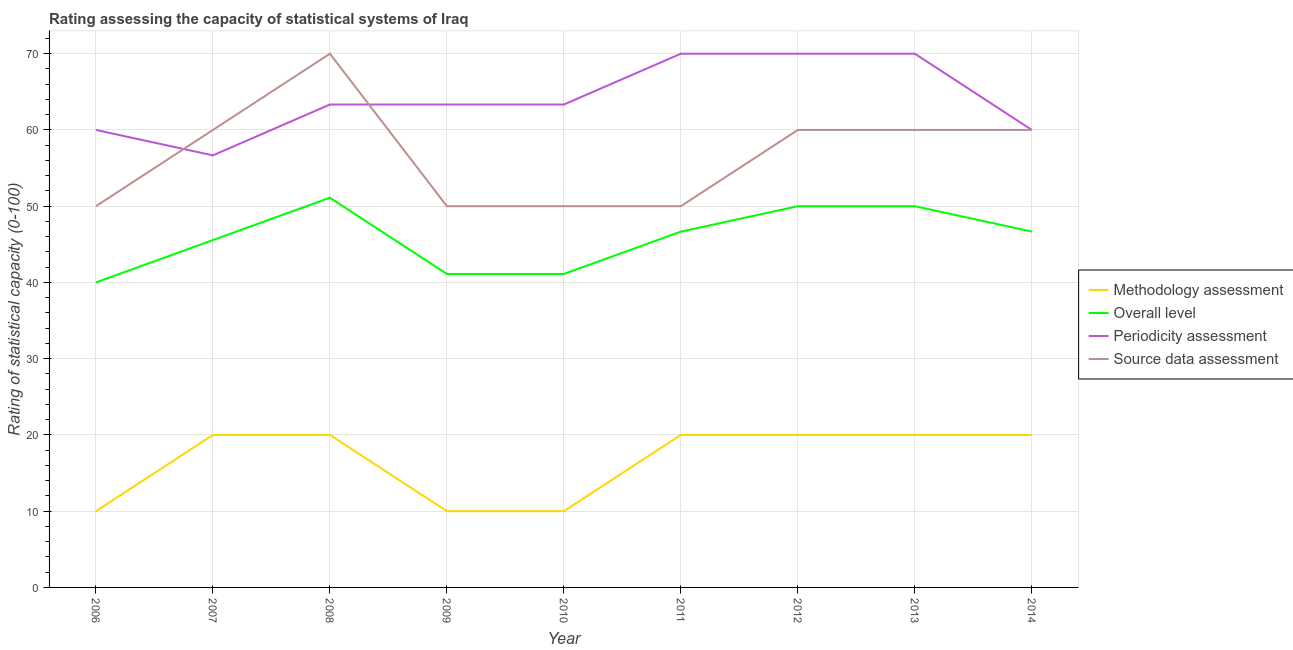Does the line corresponding to overall level rating intersect with the line corresponding to source data assessment rating?
Your response must be concise. No. What is the methodology assessment rating in 2010?
Your answer should be very brief. 10. Across all years, what is the maximum methodology assessment rating?
Your answer should be very brief. 20. Across all years, what is the minimum periodicity assessment rating?
Make the answer very short. 56.67. In which year was the methodology assessment rating minimum?
Ensure brevity in your answer.  2006. What is the total periodicity assessment rating in the graph?
Give a very brief answer. 576.67. What is the difference between the periodicity assessment rating in 2006 and that in 2009?
Provide a succinct answer. -3.33. What is the difference between the overall level rating in 2006 and the periodicity assessment rating in 2010?
Offer a very short reply. -23.33. What is the average source data assessment rating per year?
Offer a terse response. 56.67. What is the difference between the highest and the second highest periodicity assessment rating?
Provide a short and direct response. 0. What is the difference between the highest and the lowest methodology assessment rating?
Keep it short and to the point. 10. In how many years, is the source data assessment rating greater than the average source data assessment rating taken over all years?
Offer a very short reply. 5. Is it the case that in every year, the sum of the methodology assessment rating and overall level rating is greater than the periodicity assessment rating?
Your answer should be very brief. No. Is the periodicity assessment rating strictly greater than the source data assessment rating over the years?
Provide a succinct answer. No. Is the methodology assessment rating strictly less than the source data assessment rating over the years?
Provide a succinct answer. Yes. How many lines are there?
Your answer should be very brief. 4. How many years are there in the graph?
Provide a short and direct response. 9. Are the values on the major ticks of Y-axis written in scientific E-notation?
Ensure brevity in your answer.  No. Does the graph contain any zero values?
Give a very brief answer. No. How are the legend labels stacked?
Offer a terse response. Vertical. What is the title of the graph?
Your response must be concise. Rating assessing the capacity of statistical systems of Iraq. What is the label or title of the Y-axis?
Provide a short and direct response. Rating of statistical capacity (0-100). What is the Rating of statistical capacity (0-100) in Methodology assessment in 2006?
Your response must be concise. 10. What is the Rating of statistical capacity (0-100) of Periodicity assessment in 2006?
Make the answer very short. 60. What is the Rating of statistical capacity (0-100) in Source data assessment in 2006?
Give a very brief answer. 50. What is the Rating of statistical capacity (0-100) in Methodology assessment in 2007?
Offer a terse response. 20. What is the Rating of statistical capacity (0-100) in Overall level in 2007?
Ensure brevity in your answer.  45.56. What is the Rating of statistical capacity (0-100) of Periodicity assessment in 2007?
Keep it short and to the point. 56.67. What is the Rating of statistical capacity (0-100) of Overall level in 2008?
Make the answer very short. 51.11. What is the Rating of statistical capacity (0-100) in Periodicity assessment in 2008?
Make the answer very short. 63.33. What is the Rating of statistical capacity (0-100) of Methodology assessment in 2009?
Your answer should be compact. 10. What is the Rating of statistical capacity (0-100) of Overall level in 2009?
Your response must be concise. 41.11. What is the Rating of statistical capacity (0-100) of Periodicity assessment in 2009?
Give a very brief answer. 63.33. What is the Rating of statistical capacity (0-100) in Methodology assessment in 2010?
Give a very brief answer. 10. What is the Rating of statistical capacity (0-100) in Overall level in 2010?
Provide a short and direct response. 41.11. What is the Rating of statistical capacity (0-100) in Periodicity assessment in 2010?
Offer a very short reply. 63.33. What is the Rating of statistical capacity (0-100) of Methodology assessment in 2011?
Your response must be concise. 20. What is the Rating of statistical capacity (0-100) of Overall level in 2011?
Your answer should be compact. 46.67. What is the Rating of statistical capacity (0-100) of Periodicity assessment in 2012?
Your answer should be very brief. 70. What is the Rating of statistical capacity (0-100) of Methodology assessment in 2013?
Ensure brevity in your answer.  20. What is the Rating of statistical capacity (0-100) of Overall level in 2013?
Provide a succinct answer. 50. What is the Rating of statistical capacity (0-100) of Periodicity assessment in 2013?
Give a very brief answer. 70. What is the Rating of statistical capacity (0-100) in Methodology assessment in 2014?
Your answer should be compact. 20. What is the Rating of statistical capacity (0-100) of Overall level in 2014?
Make the answer very short. 46.67. What is the Rating of statistical capacity (0-100) in Periodicity assessment in 2014?
Your answer should be very brief. 60. Across all years, what is the maximum Rating of statistical capacity (0-100) in Overall level?
Keep it short and to the point. 51.11. Across all years, what is the maximum Rating of statistical capacity (0-100) of Source data assessment?
Provide a succinct answer. 70. Across all years, what is the minimum Rating of statistical capacity (0-100) of Methodology assessment?
Keep it short and to the point. 10. Across all years, what is the minimum Rating of statistical capacity (0-100) in Periodicity assessment?
Provide a short and direct response. 56.67. What is the total Rating of statistical capacity (0-100) of Methodology assessment in the graph?
Give a very brief answer. 150. What is the total Rating of statistical capacity (0-100) of Overall level in the graph?
Your response must be concise. 412.22. What is the total Rating of statistical capacity (0-100) in Periodicity assessment in the graph?
Give a very brief answer. 576.67. What is the total Rating of statistical capacity (0-100) of Source data assessment in the graph?
Keep it short and to the point. 510. What is the difference between the Rating of statistical capacity (0-100) in Overall level in 2006 and that in 2007?
Provide a succinct answer. -5.56. What is the difference between the Rating of statistical capacity (0-100) in Periodicity assessment in 2006 and that in 2007?
Your answer should be very brief. 3.33. What is the difference between the Rating of statistical capacity (0-100) in Source data assessment in 2006 and that in 2007?
Your answer should be compact. -10. What is the difference between the Rating of statistical capacity (0-100) in Overall level in 2006 and that in 2008?
Give a very brief answer. -11.11. What is the difference between the Rating of statistical capacity (0-100) in Source data assessment in 2006 and that in 2008?
Keep it short and to the point. -20. What is the difference between the Rating of statistical capacity (0-100) in Overall level in 2006 and that in 2009?
Provide a succinct answer. -1.11. What is the difference between the Rating of statistical capacity (0-100) in Source data assessment in 2006 and that in 2009?
Offer a very short reply. 0. What is the difference between the Rating of statistical capacity (0-100) of Overall level in 2006 and that in 2010?
Provide a short and direct response. -1.11. What is the difference between the Rating of statistical capacity (0-100) of Periodicity assessment in 2006 and that in 2010?
Offer a terse response. -3.33. What is the difference between the Rating of statistical capacity (0-100) of Source data assessment in 2006 and that in 2010?
Offer a terse response. 0. What is the difference between the Rating of statistical capacity (0-100) of Methodology assessment in 2006 and that in 2011?
Provide a short and direct response. -10. What is the difference between the Rating of statistical capacity (0-100) of Overall level in 2006 and that in 2011?
Your answer should be very brief. -6.67. What is the difference between the Rating of statistical capacity (0-100) in Periodicity assessment in 2006 and that in 2011?
Provide a succinct answer. -10. What is the difference between the Rating of statistical capacity (0-100) in Source data assessment in 2006 and that in 2011?
Give a very brief answer. 0. What is the difference between the Rating of statistical capacity (0-100) of Periodicity assessment in 2006 and that in 2012?
Ensure brevity in your answer.  -10. What is the difference between the Rating of statistical capacity (0-100) of Methodology assessment in 2006 and that in 2013?
Give a very brief answer. -10. What is the difference between the Rating of statistical capacity (0-100) of Overall level in 2006 and that in 2013?
Offer a very short reply. -10. What is the difference between the Rating of statistical capacity (0-100) of Periodicity assessment in 2006 and that in 2013?
Provide a succinct answer. -10. What is the difference between the Rating of statistical capacity (0-100) of Overall level in 2006 and that in 2014?
Your response must be concise. -6.67. What is the difference between the Rating of statistical capacity (0-100) of Periodicity assessment in 2006 and that in 2014?
Give a very brief answer. 0. What is the difference between the Rating of statistical capacity (0-100) of Source data assessment in 2006 and that in 2014?
Make the answer very short. -10. What is the difference between the Rating of statistical capacity (0-100) of Overall level in 2007 and that in 2008?
Your answer should be very brief. -5.56. What is the difference between the Rating of statistical capacity (0-100) of Periodicity assessment in 2007 and that in 2008?
Keep it short and to the point. -6.67. What is the difference between the Rating of statistical capacity (0-100) of Source data assessment in 2007 and that in 2008?
Your response must be concise. -10. What is the difference between the Rating of statistical capacity (0-100) of Methodology assessment in 2007 and that in 2009?
Offer a very short reply. 10. What is the difference between the Rating of statistical capacity (0-100) of Overall level in 2007 and that in 2009?
Your answer should be very brief. 4.44. What is the difference between the Rating of statistical capacity (0-100) of Periodicity assessment in 2007 and that in 2009?
Provide a succinct answer. -6.67. What is the difference between the Rating of statistical capacity (0-100) of Methodology assessment in 2007 and that in 2010?
Your response must be concise. 10. What is the difference between the Rating of statistical capacity (0-100) of Overall level in 2007 and that in 2010?
Provide a short and direct response. 4.44. What is the difference between the Rating of statistical capacity (0-100) of Periodicity assessment in 2007 and that in 2010?
Make the answer very short. -6.67. What is the difference between the Rating of statistical capacity (0-100) in Overall level in 2007 and that in 2011?
Provide a short and direct response. -1.11. What is the difference between the Rating of statistical capacity (0-100) of Periodicity assessment in 2007 and that in 2011?
Offer a terse response. -13.33. What is the difference between the Rating of statistical capacity (0-100) in Source data assessment in 2007 and that in 2011?
Offer a terse response. 10. What is the difference between the Rating of statistical capacity (0-100) in Methodology assessment in 2007 and that in 2012?
Your answer should be compact. 0. What is the difference between the Rating of statistical capacity (0-100) of Overall level in 2007 and that in 2012?
Give a very brief answer. -4.44. What is the difference between the Rating of statistical capacity (0-100) of Periodicity assessment in 2007 and that in 2012?
Your answer should be compact. -13.33. What is the difference between the Rating of statistical capacity (0-100) in Source data assessment in 2007 and that in 2012?
Offer a terse response. 0. What is the difference between the Rating of statistical capacity (0-100) of Methodology assessment in 2007 and that in 2013?
Provide a succinct answer. 0. What is the difference between the Rating of statistical capacity (0-100) of Overall level in 2007 and that in 2013?
Provide a short and direct response. -4.44. What is the difference between the Rating of statistical capacity (0-100) in Periodicity assessment in 2007 and that in 2013?
Keep it short and to the point. -13.33. What is the difference between the Rating of statistical capacity (0-100) of Source data assessment in 2007 and that in 2013?
Offer a terse response. 0. What is the difference between the Rating of statistical capacity (0-100) of Overall level in 2007 and that in 2014?
Offer a very short reply. -1.11. What is the difference between the Rating of statistical capacity (0-100) in Periodicity assessment in 2007 and that in 2014?
Offer a very short reply. -3.33. What is the difference between the Rating of statistical capacity (0-100) in Overall level in 2008 and that in 2009?
Your response must be concise. 10. What is the difference between the Rating of statistical capacity (0-100) in Periodicity assessment in 2008 and that in 2009?
Keep it short and to the point. 0. What is the difference between the Rating of statistical capacity (0-100) in Source data assessment in 2008 and that in 2009?
Provide a short and direct response. 20. What is the difference between the Rating of statistical capacity (0-100) in Methodology assessment in 2008 and that in 2010?
Give a very brief answer. 10. What is the difference between the Rating of statistical capacity (0-100) in Overall level in 2008 and that in 2011?
Provide a succinct answer. 4.44. What is the difference between the Rating of statistical capacity (0-100) in Periodicity assessment in 2008 and that in 2011?
Your answer should be compact. -6.67. What is the difference between the Rating of statistical capacity (0-100) of Source data assessment in 2008 and that in 2011?
Ensure brevity in your answer.  20. What is the difference between the Rating of statistical capacity (0-100) in Methodology assessment in 2008 and that in 2012?
Your answer should be compact. 0. What is the difference between the Rating of statistical capacity (0-100) in Periodicity assessment in 2008 and that in 2012?
Offer a very short reply. -6.67. What is the difference between the Rating of statistical capacity (0-100) of Source data assessment in 2008 and that in 2012?
Offer a terse response. 10. What is the difference between the Rating of statistical capacity (0-100) of Overall level in 2008 and that in 2013?
Offer a very short reply. 1.11. What is the difference between the Rating of statistical capacity (0-100) of Periodicity assessment in 2008 and that in 2013?
Your response must be concise. -6.67. What is the difference between the Rating of statistical capacity (0-100) in Source data assessment in 2008 and that in 2013?
Ensure brevity in your answer.  10. What is the difference between the Rating of statistical capacity (0-100) of Overall level in 2008 and that in 2014?
Your answer should be compact. 4.44. What is the difference between the Rating of statistical capacity (0-100) in Periodicity assessment in 2008 and that in 2014?
Your answer should be compact. 3.33. What is the difference between the Rating of statistical capacity (0-100) of Source data assessment in 2008 and that in 2014?
Your response must be concise. 10. What is the difference between the Rating of statistical capacity (0-100) in Methodology assessment in 2009 and that in 2010?
Offer a very short reply. 0. What is the difference between the Rating of statistical capacity (0-100) of Methodology assessment in 2009 and that in 2011?
Make the answer very short. -10. What is the difference between the Rating of statistical capacity (0-100) of Overall level in 2009 and that in 2011?
Your answer should be very brief. -5.56. What is the difference between the Rating of statistical capacity (0-100) in Periodicity assessment in 2009 and that in 2011?
Make the answer very short. -6.67. What is the difference between the Rating of statistical capacity (0-100) in Source data assessment in 2009 and that in 2011?
Offer a terse response. 0. What is the difference between the Rating of statistical capacity (0-100) in Overall level in 2009 and that in 2012?
Offer a very short reply. -8.89. What is the difference between the Rating of statistical capacity (0-100) in Periodicity assessment in 2009 and that in 2012?
Offer a very short reply. -6.67. What is the difference between the Rating of statistical capacity (0-100) of Source data assessment in 2009 and that in 2012?
Provide a succinct answer. -10. What is the difference between the Rating of statistical capacity (0-100) of Methodology assessment in 2009 and that in 2013?
Provide a succinct answer. -10. What is the difference between the Rating of statistical capacity (0-100) of Overall level in 2009 and that in 2013?
Your answer should be very brief. -8.89. What is the difference between the Rating of statistical capacity (0-100) of Periodicity assessment in 2009 and that in 2013?
Provide a short and direct response. -6.67. What is the difference between the Rating of statistical capacity (0-100) in Overall level in 2009 and that in 2014?
Offer a very short reply. -5.56. What is the difference between the Rating of statistical capacity (0-100) of Overall level in 2010 and that in 2011?
Your answer should be very brief. -5.56. What is the difference between the Rating of statistical capacity (0-100) of Periodicity assessment in 2010 and that in 2011?
Your answer should be very brief. -6.67. What is the difference between the Rating of statistical capacity (0-100) in Source data assessment in 2010 and that in 2011?
Keep it short and to the point. 0. What is the difference between the Rating of statistical capacity (0-100) of Overall level in 2010 and that in 2012?
Give a very brief answer. -8.89. What is the difference between the Rating of statistical capacity (0-100) in Periodicity assessment in 2010 and that in 2012?
Your response must be concise. -6.67. What is the difference between the Rating of statistical capacity (0-100) in Source data assessment in 2010 and that in 2012?
Offer a very short reply. -10. What is the difference between the Rating of statistical capacity (0-100) of Methodology assessment in 2010 and that in 2013?
Your response must be concise. -10. What is the difference between the Rating of statistical capacity (0-100) in Overall level in 2010 and that in 2013?
Ensure brevity in your answer.  -8.89. What is the difference between the Rating of statistical capacity (0-100) in Periodicity assessment in 2010 and that in 2013?
Provide a short and direct response. -6.67. What is the difference between the Rating of statistical capacity (0-100) of Source data assessment in 2010 and that in 2013?
Offer a terse response. -10. What is the difference between the Rating of statistical capacity (0-100) in Methodology assessment in 2010 and that in 2014?
Ensure brevity in your answer.  -10. What is the difference between the Rating of statistical capacity (0-100) in Overall level in 2010 and that in 2014?
Offer a terse response. -5.56. What is the difference between the Rating of statistical capacity (0-100) in Source data assessment in 2010 and that in 2014?
Ensure brevity in your answer.  -10. What is the difference between the Rating of statistical capacity (0-100) of Overall level in 2011 and that in 2012?
Ensure brevity in your answer.  -3.33. What is the difference between the Rating of statistical capacity (0-100) in Methodology assessment in 2011 and that in 2013?
Provide a succinct answer. 0. What is the difference between the Rating of statistical capacity (0-100) of Overall level in 2011 and that in 2013?
Provide a short and direct response. -3.33. What is the difference between the Rating of statistical capacity (0-100) of Periodicity assessment in 2011 and that in 2013?
Keep it short and to the point. 0. What is the difference between the Rating of statistical capacity (0-100) of Periodicity assessment in 2011 and that in 2014?
Your response must be concise. 10. What is the difference between the Rating of statistical capacity (0-100) of Source data assessment in 2011 and that in 2014?
Offer a terse response. -10. What is the difference between the Rating of statistical capacity (0-100) of Overall level in 2012 and that in 2013?
Your answer should be very brief. 0. What is the difference between the Rating of statistical capacity (0-100) in Periodicity assessment in 2012 and that in 2013?
Your answer should be compact. 0. What is the difference between the Rating of statistical capacity (0-100) in Source data assessment in 2012 and that in 2013?
Your response must be concise. 0. What is the difference between the Rating of statistical capacity (0-100) of Source data assessment in 2012 and that in 2014?
Offer a terse response. 0. What is the difference between the Rating of statistical capacity (0-100) in Source data assessment in 2013 and that in 2014?
Keep it short and to the point. 0. What is the difference between the Rating of statistical capacity (0-100) in Methodology assessment in 2006 and the Rating of statistical capacity (0-100) in Overall level in 2007?
Your answer should be compact. -35.56. What is the difference between the Rating of statistical capacity (0-100) in Methodology assessment in 2006 and the Rating of statistical capacity (0-100) in Periodicity assessment in 2007?
Your answer should be very brief. -46.67. What is the difference between the Rating of statistical capacity (0-100) of Overall level in 2006 and the Rating of statistical capacity (0-100) of Periodicity assessment in 2007?
Your answer should be very brief. -16.67. What is the difference between the Rating of statistical capacity (0-100) of Periodicity assessment in 2006 and the Rating of statistical capacity (0-100) of Source data assessment in 2007?
Give a very brief answer. 0. What is the difference between the Rating of statistical capacity (0-100) of Methodology assessment in 2006 and the Rating of statistical capacity (0-100) of Overall level in 2008?
Give a very brief answer. -41.11. What is the difference between the Rating of statistical capacity (0-100) of Methodology assessment in 2006 and the Rating of statistical capacity (0-100) of Periodicity assessment in 2008?
Your response must be concise. -53.33. What is the difference between the Rating of statistical capacity (0-100) of Methodology assessment in 2006 and the Rating of statistical capacity (0-100) of Source data assessment in 2008?
Offer a very short reply. -60. What is the difference between the Rating of statistical capacity (0-100) of Overall level in 2006 and the Rating of statistical capacity (0-100) of Periodicity assessment in 2008?
Give a very brief answer. -23.33. What is the difference between the Rating of statistical capacity (0-100) of Overall level in 2006 and the Rating of statistical capacity (0-100) of Source data assessment in 2008?
Your answer should be very brief. -30. What is the difference between the Rating of statistical capacity (0-100) of Methodology assessment in 2006 and the Rating of statistical capacity (0-100) of Overall level in 2009?
Offer a very short reply. -31.11. What is the difference between the Rating of statistical capacity (0-100) in Methodology assessment in 2006 and the Rating of statistical capacity (0-100) in Periodicity assessment in 2009?
Ensure brevity in your answer.  -53.33. What is the difference between the Rating of statistical capacity (0-100) of Overall level in 2006 and the Rating of statistical capacity (0-100) of Periodicity assessment in 2009?
Your response must be concise. -23.33. What is the difference between the Rating of statistical capacity (0-100) of Overall level in 2006 and the Rating of statistical capacity (0-100) of Source data assessment in 2009?
Provide a short and direct response. -10. What is the difference between the Rating of statistical capacity (0-100) of Periodicity assessment in 2006 and the Rating of statistical capacity (0-100) of Source data assessment in 2009?
Your answer should be very brief. 10. What is the difference between the Rating of statistical capacity (0-100) of Methodology assessment in 2006 and the Rating of statistical capacity (0-100) of Overall level in 2010?
Provide a succinct answer. -31.11. What is the difference between the Rating of statistical capacity (0-100) in Methodology assessment in 2006 and the Rating of statistical capacity (0-100) in Periodicity assessment in 2010?
Provide a succinct answer. -53.33. What is the difference between the Rating of statistical capacity (0-100) in Methodology assessment in 2006 and the Rating of statistical capacity (0-100) in Source data assessment in 2010?
Ensure brevity in your answer.  -40. What is the difference between the Rating of statistical capacity (0-100) of Overall level in 2006 and the Rating of statistical capacity (0-100) of Periodicity assessment in 2010?
Keep it short and to the point. -23.33. What is the difference between the Rating of statistical capacity (0-100) of Overall level in 2006 and the Rating of statistical capacity (0-100) of Source data assessment in 2010?
Provide a short and direct response. -10. What is the difference between the Rating of statistical capacity (0-100) in Methodology assessment in 2006 and the Rating of statistical capacity (0-100) in Overall level in 2011?
Provide a succinct answer. -36.67. What is the difference between the Rating of statistical capacity (0-100) in Methodology assessment in 2006 and the Rating of statistical capacity (0-100) in Periodicity assessment in 2011?
Give a very brief answer. -60. What is the difference between the Rating of statistical capacity (0-100) in Periodicity assessment in 2006 and the Rating of statistical capacity (0-100) in Source data assessment in 2011?
Your answer should be compact. 10. What is the difference between the Rating of statistical capacity (0-100) of Methodology assessment in 2006 and the Rating of statistical capacity (0-100) of Overall level in 2012?
Your answer should be compact. -40. What is the difference between the Rating of statistical capacity (0-100) of Methodology assessment in 2006 and the Rating of statistical capacity (0-100) of Periodicity assessment in 2012?
Provide a succinct answer. -60. What is the difference between the Rating of statistical capacity (0-100) of Methodology assessment in 2006 and the Rating of statistical capacity (0-100) of Source data assessment in 2012?
Your answer should be compact. -50. What is the difference between the Rating of statistical capacity (0-100) of Overall level in 2006 and the Rating of statistical capacity (0-100) of Periodicity assessment in 2012?
Provide a succinct answer. -30. What is the difference between the Rating of statistical capacity (0-100) in Overall level in 2006 and the Rating of statistical capacity (0-100) in Source data assessment in 2012?
Offer a terse response. -20. What is the difference between the Rating of statistical capacity (0-100) of Periodicity assessment in 2006 and the Rating of statistical capacity (0-100) of Source data assessment in 2012?
Provide a short and direct response. 0. What is the difference between the Rating of statistical capacity (0-100) in Methodology assessment in 2006 and the Rating of statistical capacity (0-100) in Periodicity assessment in 2013?
Give a very brief answer. -60. What is the difference between the Rating of statistical capacity (0-100) in Methodology assessment in 2006 and the Rating of statistical capacity (0-100) in Source data assessment in 2013?
Provide a short and direct response. -50. What is the difference between the Rating of statistical capacity (0-100) in Periodicity assessment in 2006 and the Rating of statistical capacity (0-100) in Source data assessment in 2013?
Offer a terse response. 0. What is the difference between the Rating of statistical capacity (0-100) of Methodology assessment in 2006 and the Rating of statistical capacity (0-100) of Overall level in 2014?
Keep it short and to the point. -36.67. What is the difference between the Rating of statistical capacity (0-100) of Methodology assessment in 2006 and the Rating of statistical capacity (0-100) of Periodicity assessment in 2014?
Provide a succinct answer. -50. What is the difference between the Rating of statistical capacity (0-100) of Methodology assessment in 2006 and the Rating of statistical capacity (0-100) of Source data assessment in 2014?
Keep it short and to the point. -50. What is the difference between the Rating of statistical capacity (0-100) of Methodology assessment in 2007 and the Rating of statistical capacity (0-100) of Overall level in 2008?
Offer a terse response. -31.11. What is the difference between the Rating of statistical capacity (0-100) of Methodology assessment in 2007 and the Rating of statistical capacity (0-100) of Periodicity assessment in 2008?
Offer a terse response. -43.33. What is the difference between the Rating of statistical capacity (0-100) of Overall level in 2007 and the Rating of statistical capacity (0-100) of Periodicity assessment in 2008?
Your answer should be very brief. -17.78. What is the difference between the Rating of statistical capacity (0-100) of Overall level in 2007 and the Rating of statistical capacity (0-100) of Source data assessment in 2008?
Ensure brevity in your answer.  -24.44. What is the difference between the Rating of statistical capacity (0-100) in Periodicity assessment in 2007 and the Rating of statistical capacity (0-100) in Source data assessment in 2008?
Your answer should be very brief. -13.33. What is the difference between the Rating of statistical capacity (0-100) of Methodology assessment in 2007 and the Rating of statistical capacity (0-100) of Overall level in 2009?
Provide a short and direct response. -21.11. What is the difference between the Rating of statistical capacity (0-100) of Methodology assessment in 2007 and the Rating of statistical capacity (0-100) of Periodicity assessment in 2009?
Offer a very short reply. -43.33. What is the difference between the Rating of statistical capacity (0-100) in Overall level in 2007 and the Rating of statistical capacity (0-100) in Periodicity assessment in 2009?
Keep it short and to the point. -17.78. What is the difference between the Rating of statistical capacity (0-100) of Overall level in 2007 and the Rating of statistical capacity (0-100) of Source data assessment in 2009?
Ensure brevity in your answer.  -4.44. What is the difference between the Rating of statistical capacity (0-100) in Periodicity assessment in 2007 and the Rating of statistical capacity (0-100) in Source data assessment in 2009?
Make the answer very short. 6.67. What is the difference between the Rating of statistical capacity (0-100) of Methodology assessment in 2007 and the Rating of statistical capacity (0-100) of Overall level in 2010?
Provide a short and direct response. -21.11. What is the difference between the Rating of statistical capacity (0-100) in Methodology assessment in 2007 and the Rating of statistical capacity (0-100) in Periodicity assessment in 2010?
Provide a succinct answer. -43.33. What is the difference between the Rating of statistical capacity (0-100) in Methodology assessment in 2007 and the Rating of statistical capacity (0-100) in Source data assessment in 2010?
Ensure brevity in your answer.  -30. What is the difference between the Rating of statistical capacity (0-100) in Overall level in 2007 and the Rating of statistical capacity (0-100) in Periodicity assessment in 2010?
Your answer should be very brief. -17.78. What is the difference between the Rating of statistical capacity (0-100) of Overall level in 2007 and the Rating of statistical capacity (0-100) of Source data assessment in 2010?
Make the answer very short. -4.44. What is the difference between the Rating of statistical capacity (0-100) of Methodology assessment in 2007 and the Rating of statistical capacity (0-100) of Overall level in 2011?
Offer a very short reply. -26.67. What is the difference between the Rating of statistical capacity (0-100) in Overall level in 2007 and the Rating of statistical capacity (0-100) in Periodicity assessment in 2011?
Make the answer very short. -24.44. What is the difference between the Rating of statistical capacity (0-100) of Overall level in 2007 and the Rating of statistical capacity (0-100) of Source data assessment in 2011?
Provide a succinct answer. -4.44. What is the difference between the Rating of statistical capacity (0-100) in Periodicity assessment in 2007 and the Rating of statistical capacity (0-100) in Source data assessment in 2011?
Your answer should be very brief. 6.67. What is the difference between the Rating of statistical capacity (0-100) of Methodology assessment in 2007 and the Rating of statistical capacity (0-100) of Periodicity assessment in 2012?
Your answer should be compact. -50. What is the difference between the Rating of statistical capacity (0-100) of Overall level in 2007 and the Rating of statistical capacity (0-100) of Periodicity assessment in 2012?
Provide a short and direct response. -24.44. What is the difference between the Rating of statistical capacity (0-100) of Overall level in 2007 and the Rating of statistical capacity (0-100) of Source data assessment in 2012?
Offer a terse response. -14.44. What is the difference between the Rating of statistical capacity (0-100) of Periodicity assessment in 2007 and the Rating of statistical capacity (0-100) of Source data assessment in 2012?
Keep it short and to the point. -3.33. What is the difference between the Rating of statistical capacity (0-100) of Methodology assessment in 2007 and the Rating of statistical capacity (0-100) of Source data assessment in 2013?
Offer a terse response. -40. What is the difference between the Rating of statistical capacity (0-100) of Overall level in 2007 and the Rating of statistical capacity (0-100) of Periodicity assessment in 2013?
Offer a very short reply. -24.44. What is the difference between the Rating of statistical capacity (0-100) of Overall level in 2007 and the Rating of statistical capacity (0-100) of Source data assessment in 2013?
Keep it short and to the point. -14.44. What is the difference between the Rating of statistical capacity (0-100) in Periodicity assessment in 2007 and the Rating of statistical capacity (0-100) in Source data assessment in 2013?
Make the answer very short. -3.33. What is the difference between the Rating of statistical capacity (0-100) of Methodology assessment in 2007 and the Rating of statistical capacity (0-100) of Overall level in 2014?
Give a very brief answer. -26.67. What is the difference between the Rating of statistical capacity (0-100) of Methodology assessment in 2007 and the Rating of statistical capacity (0-100) of Periodicity assessment in 2014?
Offer a terse response. -40. What is the difference between the Rating of statistical capacity (0-100) in Methodology assessment in 2007 and the Rating of statistical capacity (0-100) in Source data assessment in 2014?
Offer a terse response. -40. What is the difference between the Rating of statistical capacity (0-100) in Overall level in 2007 and the Rating of statistical capacity (0-100) in Periodicity assessment in 2014?
Offer a terse response. -14.44. What is the difference between the Rating of statistical capacity (0-100) of Overall level in 2007 and the Rating of statistical capacity (0-100) of Source data assessment in 2014?
Make the answer very short. -14.44. What is the difference between the Rating of statistical capacity (0-100) in Methodology assessment in 2008 and the Rating of statistical capacity (0-100) in Overall level in 2009?
Keep it short and to the point. -21.11. What is the difference between the Rating of statistical capacity (0-100) in Methodology assessment in 2008 and the Rating of statistical capacity (0-100) in Periodicity assessment in 2009?
Give a very brief answer. -43.33. What is the difference between the Rating of statistical capacity (0-100) of Overall level in 2008 and the Rating of statistical capacity (0-100) of Periodicity assessment in 2009?
Your answer should be compact. -12.22. What is the difference between the Rating of statistical capacity (0-100) in Overall level in 2008 and the Rating of statistical capacity (0-100) in Source data assessment in 2009?
Provide a succinct answer. 1.11. What is the difference between the Rating of statistical capacity (0-100) in Periodicity assessment in 2008 and the Rating of statistical capacity (0-100) in Source data assessment in 2009?
Provide a short and direct response. 13.33. What is the difference between the Rating of statistical capacity (0-100) of Methodology assessment in 2008 and the Rating of statistical capacity (0-100) of Overall level in 2010?
Your response must be concise. -21.11. What is the difference between the Rating of statistical capacity (0-100) of Methodology assessment in 2008 and the Rating of statistical capacity (0-100) of Periodicity assessment in 2010?
Your response must be concise. -43.33. What is the difference between the Rating of statistical capacity (0-100) of Overall level in 2008 and the Rating of statistical capacity (0-100) of Periodicity assessment in 2010?
Your answer should be compact. -12.22. What is the difference between the Rating of statistical capacity (0-100) of Overall level in 2008 and the Rating of statistical capacity (0-100) of Source data assessment in 2010?
Keep it short and to the point. 1.11. What is the difference between the Rating of statistical capacity (0-100) of Periodicity assessment in 2008 and the Rating of statistical capacity (0-100) of Source data assessment in 2010?
Offer a very short reply. 13.33. What is the difference between the Rating of statistical capacity (0-100) in Methodology assessment in 2008 and the Rating of statistical capacity (0-100) in Overall level in 2011?
Give a very brief answer. -26.67. What is the difference between the Rating of statistical capacity (0-100) in Methodology assessment in 2008 and the Rating of statistical capacity (0-100) in Periodicity assessment in 2011?
Your answer should be compact. -50. What is the difference between the Rating of statistical capacity (0-100) of Overall level in 2008 and the Rating of statistical capacity (0-100) of Periodicity assessment in 2011?
Provide a succinct answer. -18.89. What is the difference between the Rating of statistical capacity (0-100) of Overall level in 2008 and the Rating of statistical capacity (0-100) of Source data assessment in 2011?
Keep it short and to the point. 1.11. What is the difference between the Rating of statistical capacity (0-100) of Periodicity assessment in 2008 and the Rating of statistical capacity (0-100) of Source data assessment in 2011?
Ensure brevity in your answer.  13.33. What is the difference between the Rating of statistical capacity (0-100) of Methodology assessment in 2008 and the Rating of statistical capacity (0-100) of Periodicity assessment in 2012?
Provide a short and direct response. -50. What is the difference between the Rating of statistical capacity (0-100) in Overall level in 2008 and the Rating of statistical capacity (0-100) in Periodicity assessment in 2012?
Make the answer very short. -18.89. What is the difference between the Rating of statistical capacity (0-100) of Overall level in 2008 and the Rating of statistical capacity (0-100) of Source data assessment in 2012?
Provide a short and direct response. -8.89. What is the difference between the Rating of statistical capacity (0-100) in Methodology assessment in 2008 and the Rating of statistical capacity (0-100) in Overall level in 2013?
Provide a succinct answer. -30. What is the difference between the Rating of statistical capacity (0-100) in Overall level in 2008 and the Rating of statistical capacity (0-100) in Periodicity assessment in 2013?
Offer a terse response. -18.89. What is the difference between the Rating of statistical capacity (0-100) of Overall level in 2008 and the Rating of statistical capacity (0-100) of Source data assessment in 2013?
Provide a short and direct response. -8.89. What is the difference between the Rating of statistical capacity (0-100) of Periodicity assessment in 2008 and the Rating of statistical capacity (0-100) of Source data assessment in 2013?
Provide a succinct answer. 3.33. What is the difference between the Rating of statistical capacity (0-100) in Methodology assessment in 2008 and the Rating of statistical capacity (0-100) in Overall level in 2014?
Your response must be concise. -26.67. What is the difference between the Rating of statistical capacity (0-100) in Methodology assessment in 2008 and the Rating of statistical capacity (0-100) in Source data assessment in 2014?
Make the answer very short. -40. What is the difference between the Rating of statistical capacity (0-100) in Overall level in 2008 and the Rating of statistical capacity (0-100) in Periodicity assessment in 2014?
Keep it short and to the point. -8.89. What is the difference between the Rating of statistical capacity (0-100) in Overall level in 2008 and the Rating of statistical capacity (0-100) in Source data assessment in 2014?
Your answer should be compact. -8.89. What is the difference between the Rating of statistical capacity (0-100) in Periodicity assessment in 2008 and the Rating of statistical capacity (0-100) in Source data assessment in 2014?
Your response must be concise. 3.33. What is the difference between the Rating of statistical capacity (0-100) of Methodology assessment in 2009 and the Rating of statistical capacity (0-100) of Overall level in 2010?
Ensure brevity in your answer.  -31.11. What is the difference between the Rating of statistical capacity (0-100) of Methodology assessment in 2009 and the Rating of statistical capacity (0-100) of Periodicity assessment in 2010?
Give a very brief answer. -53.33. What is the difference between the Rating of statistical capacity (0-100) of Methodology assessment in 2009 and the Rating of statistical capacity (0-100) of Source data assessment in 2010?
Your answer should be very brief. -40. What is the difference between the Rating of statistical capacity (0-100) in Overall level in 2009 and the Rating of statistical capacity (0-100) in Periodicity assessment in 2010?
Your answer should be very brief. -22.22. What is the difference between the Rating of statistical capacity (0-100) of Overall level in 2009 and the Rating of statistical capacity (0-100) of Source data assessment in 2010?
Provide a succinct answer. -8.89. What is the difference between the Rating of statistical capacity (0-100) of Periodicity assessment in 2009 and the Rating of statistical capacity (0-100) of Source data assessment in 2010?
Ensure brevity in your answer.  13.33. What is the difference between the Rating of statistical capacity (0-100) of Methodology assessment in 2009 and the Rating of statistical capacity (0-100) of Overall level in 2011?
Give a very brief answer. -36.67. What is the difference between the Rating of statistical capacity (0-100) in Methodology assessment in 2009 and the Rating of statistical capacity (0-100) in Periodicity assessment in 2011?
Offer a very short reply. -60. What is the difference between the Rating of statistical capacity (0-100) in Overall level in 2009 and the Rating of statistical capacity (0-100) in Periodicity assessment in 2011?
Your answer should be compact. -28.89. What is the difference between the Rating of statistical capacity (0-100) of Overall level in 2009 and the Rating of statistical capacity (0-100) of Source data assessment in 2011?
Your response must be concise. -8.89. What is the difference between the Rating of statistical capacity (0-100) of Periodicity assessment in 2009 and the Rating of statistical capacity (0-100) of Source data assessment in 2011?
Your response must be concise. 13.33. What is the difference between the Rating of statistical capacity (0-100) in Methodology assessment in 2009 and the Rating of statistical capacity (0-100) in Periodicity assessment in 2012?
Make the answer very short. -60. What is the difference between the Rating of statistical capacity (0-100) of Overall level in 2009 and the Rating of statistical capacity (0-100) of Periodicity assessment in 2012?
Offer a very short reply. -28.89. What is the difference between the Rating of statistical capacity (0-100) in Overall level in 2009 and the Rating of statistical capacity (0-100) in Source data assessment in 2012?
Keep it short and to the point. -18.89. What is the difference between the Rating of statistical capacity (0-100) of Periodicity assessment in 2009 and the Rating of statistical capacity (0-100) of Source data assessment in 2012?
Give a very brief answer. 3.33. What is the difference between the Rating of statistical capacity (0-100) in Methodology assessment in 2009 and the Rating of statistical capacity (0-100) in Periodicity assessment in 2013?
Offer a terse response. -60. What is the difference between the Rating of statistical capacity (0-100) in Overall level in 2009 and the Rating of statistical capacity (0-100) in Periodicity assessment in 2013?
Provide a succinct answer. -28.89. What is the difference between the Rating of statistical capacity (0-100) in Overall level in 2009 and the Rating of statistical capacity (0-100) in Source data assessment in 2013?
Your answer should be very brief. -18.89. What is the difference between the Rating of statistical capacity (0-100) of Methodology assessment in 2009 and the Rating of statistical capacity (0-100) of Overall level in 2014?
Keep it short and to the point. -36.67. What is the difference between the Rating of statistical capacity (0-100) in Methodology assessment in 2009 and the Rating of statistical capacity (0-100) in Periodicity assessment in 2014?
Provide a short and direct response. -50. What is the difference between the Rating of statistical capacity (0-100) of Overall level in 2009 and the Rating of statistical capacity (0-100) of Periodicity assessment in 2014?
Give a very brief answer. -18.89. What is the difference between the Rating of statistical capacity (0-100) in Overall level in 2009 and the Rating of statistical capacity (0-100) in Source data assessment in 2014?
Offer a very short reply. -18.89. What is the difference between the Rating of statistical capacity (0-100) in Methodology assessment in 2010 and the Rating of statistical capacity (0-100) in Overall level in 2011?
Provide a succinct answer. -36.67. What is the difference between the Rating of statistical capacity (0-100) of Methodology assessment in 2010 and the Rating of statistical capacity (0-100) of Periodicity assessment in 2011?
Provide a succinct answer. -60. What is the difference between the Rating of statistical capacity (0-100) of Overall level in 2010 and the Rating of statistical capacity (0-100) of Periodicity assessment in 2011?
Your response must be concise. -28.89. What is the difference between the Rating of statistical capacity (0-100) of Overall level in 2010 and the Rating of statistical capacity (0-100) of Source data assessment in 2011?
Provide a succinct answer. -8.89. What is the difference between the Rating of statistical capacity (0-100) in Periodicity assessment in 2010 and the Rating of statistical capacity (0-100) in Source data assessment in 2011?
Provide a short and direct response. 13.33. What is the difference between the Rating of statistical capacity (0-100) in Methodology assessment in 2010 and the Rating of statistical capacity (0-100) in Periodicity assessment in 2012?
Offer a very short reply. -60. What is the difference between the Rating of statistical capacity (0-100) in Overall level in 2010 and the Rating of statistical capacity (0-100) in Periodicity assessment in 2012?
Make the answer very short. -28.89. What is the difference between the Rating of statistical capacity (0-100) of Overall level in 2010 and the Rating of statistical capacity (0-100) of Source data assessment in 2012?
Ensure brevity in your answer.  -18.89. What is the difference between the Rating of statistical capacity (0-100) of Periodicity assessment in 2010 and the Rating of statistical capacity (0-100) of Source data assessment in 2012?
Offer a terse response. 3.33. What is the difference between the Rating of statistical capacity (0-100) of Methodology assessment in 2010 and the Rating of statistical capacity (0-100) of Overall level in 2013?
Provide a succinct answer. -40. What is the difference between the Rating of statistical capacity (0-100) in Methodology assessment in 2010 and the Rating of statistical capacity (0-100) in Periodicity assessment in 2013?
Your answer should be compact. -60. What is the difference between the Rating of statistical capacity (0-100) in Methodology assessment in 2010 and the Rating of statistical capacity (0-100) in Source data assessment in 2013?
Give a very brief answer. -50. What is the difference between the Rating of statistical capacity (0-100) of Overall level in 2010 and the Rating of statistical capacity (0-100) of Periodicity assessment in 2013?
Offer a terse response. -28.89. What is the difference between the Rating of statistical capacity (0-100) of Overall level in 2010 and the Rating of statistical capacity (0-100) of Source data assessment in 2013?
Offer a terse response. -18.89. What is the difference between the Rating of statistical capacity (0-100) in Periodicity assessment in 2010 and the Rating of statistical capacity (0-100) in Source data assessment in 2013?
Make the answer very short. 3.33. What is the difference between the Rating of statistical capacity (0-100) of Methodology assessment in 2010 and the Rating of statistical capacity (0-100) of Overall level in 2014?
Your answer should be compact. -36.67. What is the difference between the Rating of statistical capacity (0-100) in Methodology assessment in 2010 and the Rating of statistical capacity (0-100) in Periodicity assessment in 2014?
Your answer should be compact. -50. What is the difference between the Rating of statistical capacity (0-100) in Overall level in 2010 and the Rating of statistical capacity (0-100) in Periodicity assessment in 2014?
Your response must be concise. -18.89. What is the difference between the Rating of statistical capacity (0-100) in Overall level in 2010 and the Rating of statistical capacity (0-100) in Source data assessment in 2014?
Make the answer very short. -18.89. What is the difference between the Rating of statistical capacity (0-100) of Periodicity assessment in 2010 and the Rating of statistical capacity (0-100) of Source data assessment in 2014?
Keep it short and to the point. 3.33. What is the difference between the Rating of statistical capacity (0-100) in Methodology assessment in 2011 and the Rating of statistical capacity (0-100) in Overall level in 2012?
Your answer should be very brief. -30. What is the difference between the Rating of statistical capacity (0-100) in Methodology assessment in 2011 and the Rating of statistical capacity (0-100) in Periodicity assessment in 2012?
Make the answer very short. -50. What is the difference between the Rating of statistical capacity (0-100) in Overall level in 2011 and the Rating of statistical capacity (0-100) in Periodicity assessment in 2012?
Give a very brief answer. -23.33. What is the difference between the Rating of statistical capacity (0-100) of Overall level in 2011 and the Rating of statistical capacity (0-100) of Source data assessment in 2012?
Provide a short and direct response. -13.33. What is the difference between the Rating of statistical capacity (0-100) in Methodology assessment in 2011 and the Rating of statistical capacity (0-100) in Overall level in 2013?
Ensure brevity in your answer.  -30. What is the difference between the Rating of statistical capacity (0-100) in Methodology assessment in 2011 and the Rating of statistical capacity (0-100) in Periodicity assessment in 2013?
Give a very brief answer. -50. What is the difference between the Rating of statistical capacity (0-100) in Methodology assessment in 2011 and the Rating of statistical capacity (0-100) in Source data assessment in 2013?
Keep it short and to the point. -40. What is the difference between the Rating of statistical capacity (0-100) in Overall level in 2011 and the Rating of statistical capacity (0-100) in Periodicity assessment in 2013?
Your answer should be very brief. -23.33. What is the difference between the Rating of statistical capacity (0-100) of Overall level in 2011 and the Rating of statistical capacity (0-100) of Source data assessment in 2013?
Your answer should be very brief. -13.33. What is the difference between the Rating of statistical capacity (0-100) of Methodology assessment in 2011 and the Rating of statistical capacity (0-100) of Overall level in 2014?
Your response must be concise. -26.67. What is the difference between the Rating of statistical capacity (0-100) of Methodology assessment in 2011 and the Rating of statistical capacity (0-100) of Periodicity assessment in 2014?
Keep it short and to the point. -40. What is the difference between the Rating of statistical capacity (0-100) in Methodology assessment in 2011 and the Rating of statistical capacity (0-100) in Source data assessment in 2014?
Give a very brief answer. -40. What is the difference between the Rating of statistical capacity (0-100) of Overall level in 2011 and the Rating of statistical capacity (0-100) of Periodicity assessment in 2014?
Provide a succinct answer. -13.33. What is the difference between the Rating of statistical capacity (0-100) of Overall level in 2011 and the Rating of statistical capacity (0-100) of Source data assessment in 2014?
Offer a terse response. -13.33. What is the difference between the Rating of statistical capacity (0-100) in Methodology assessment in 2012 and the Rating of statistical capacity (0-100) in Periodicity assessment in 2013?
Your response must be concise. -50. What is the difference between the Rating of statistical capacity (0-100) in Overall level in 2012 and the Rating of statistical capacity (0-100) in Source data assessment in 2013?
Provide a succinct answer. -10. What is the difference between the Rating of statistical capacity (0-100) in Periodicity assessment in 2012 and the Rating of statistical capacity (0-100) in Source data assessment in 2013?
Offer a terse response. 10. What is the difference between the Rating of statistical capacity (0-100) in Methodology assessment in 2012 and the Rating of statistical capacity (0-100) in Overall level in 2014?
Provide a succinct answer. -26.67. What is the difference between the Rating of statistical capacity (0-100) in Methodology assessment in 2012 and the Rating of statistical capacity (0-100) in Periodicity assessment in 2014?
Your response must be concise. -40. What is the difference between the Rating of statistical capacity (0-100) in Methodology assessment in 2012 and the Rating of statistical capacity (0-100) in Source data assessment in 2014?
Provide a succinct answer. -40. What is the difference between the Rating of statistical capacity (0-100) in Periodicity assessment in 2012 and the Rating of statistical capacity (0-100) in Source data assessment in 2014?
Offer a very short reply. 10. What is the difference between the Rating of statistical capacity (0-100) in Methodology assessment in 2013 and the Rating of statistical capacity (0-100) in Overall level in 2014?
Keep it short and to the point. -26.67. What is the difference between the Rating of statistical capacity (0-100) in Methodology assessment in 2013 and the Rating of statistical capacity (0-100) in Periodicity assessment in 2014?
Provide a succinct answer. -40. What is the difference between the Rating of statistical capacity (0-100) of Overall level in 2013 and the Rating of statistical capacity (0-100) of Periodicity assessment in 2014?
Provide a succinct answer. -10. What is the average Rating of statistical capacity (0-100) in Methodology assessment per year?
Offer a very short reply. 16.67. What is the average Rating of statistical capacity (0-100) of Overall level per year?
Your answer should be very brief. 45.8. What is the average Rating of statistical capacity (0-100) of Periodicity assessment per year?
Your answer should be compact. 64.07. What is the average Rating of statistical capacity (0-100) of Source data assessment per year?
Provide a succinct answer. 56.67. In the year 2006, what is the difference between the Rating of statistical capacity (0-100) of Overall level and Rating of statistical capacity (0-100) of Source data assessment?
Make the answer very short. -10. In the year 2007, what is the difference between the Rating of statistical capacity (0-100) of Methodology assessment and Rating of statistical capacity (0-100) of Overall level?
Keep it short and to the point. -25.56. In the year 2007, what is the difference between the Rating of statistical capacity (0-100) of Methodology assessment and Rating of statistical capacity (0-100) of Periodicity assessment?
Your answer should be very brief. -36.67. In the year 2007, what is the difference between the Rating of statistical capacity (0-100) of Overall level and Rating of statistical capacity (0-100) of Periodicity assessment?
Offer a very short reply. -11.11. In the year 2007, what is the difference between the Rating of statistical capacity (0-100) of Overall level and Rating of statistical capacity (0-100) of Source data assessment?
Give a very brief answer. -14.44. In the year 2007, what is the difference between the Rating of statistical capacity (0-100) in Periodicity assessment and Rating of statistical capacity (0-100) in Source data assessment?
Offer a terse response. -3.33. In the year 2008, what is the difference between the Rating of statistical capacity (0-100) of Methodology assessment and Rating of statistical capacity (0-100) of Overall level?
Make the answer very short. -31.11. In the year 2008, what is the difference between the Rating of statistical capacity (0-100) of Methodology assessment and Rating of statistical capacity (0-100) of Periodicity assessment?
Keep it short and to the point. -43.33. In the year 2008, what is the difference between the Rating of statistical capacity (0-100) of Overall level and Rating of statistical capacity (0-100) of Periodicity assessment?
Your answer should be very brief. -12.22. In the year 2008, what is the difference between the Rating of statistical capacity (0-100) of Overall level and Rating of statistical capacity (0-100) of Source data assessment?
Your answer should be compact. -18.89. In the year 2008, what is the difference between the Rating of statistical capacity (0-100) in Periodicity assessment and Rating of statistical capacity (0-100) in Source data assessment?
Keep it short and to the point. -6.67. In the year 2009, what is the difference between the Rating of statistical capacity (0-100) of Methodology assessment and Rating of statistical capacity (0-100) of Overall level?
Provide a short and direct response. -31.11. In the year 2009, what is the difference between the Rating of statistical capacity (0-100) in Methodology assessment and Rating of statistical capacity (0-100) in Periodicity assessment?
Provide a short and direct response. -53.33. In the year 2009, what is the difference between the Rating of statistical capacity (0-100) of Overall level and Rating of statistical capacity (0-100) of Periodicity assessment?
Offer a terse response. -22.22. In the year 2009, what is the difference between the Rating of statistical capacity (0-100) in Overall level and Rating of statistical capacity (0-100) in Source data assessment?
Give a very brief answer. -8.89. In the year 2009, what is the difference between the Rating of statistical capacity (0-100) in Periodicity assessment and Rating of statistical capacity (0-100) in Source data assessment?
Keep it short and to the point. 13.33. In the year 2010, what is the difference between the Rating of statistical capacity (0-100) in Methodology assessment and Rating of statistical capacity (0-100) in Overall level?
Ensure brevity in your answer.  -31.11. In the year 2010, what is the difference between the Rating of statistical capacity (0-100) in Methodology assessment and Rating of statistical capacity (0-100) in Periodicity assessment?
Provide a succinct answer. -53.33. In the year 2010, what is the difference between the Rating of statistical capacity (0-100) in Methodology assessment and Rating of statistical capacity (0-100) in Source data assessment?
Provide a short and direct response. -40. In the year 2010, what is the difference between the Rating of statistical capacity (0-100) in Overall level and Rating of statistical capacity (0-100) in Periodicity assessment?
Your response must be concise. -22.22. In the year 2010, what is the difference between the Rating of statistical capacity (0-100) of Overall level and Rating of statistical capacity (0-100) of Source data assessment?
Provide a succinct answer. -8.89. In the year 2010, what is the difference between the Rating of statistical capacity (0-100) in Periodicity assessment and Rating of statistical capacity (0-100) in Source data assessment?
Your response must be concise. 13.33. In the year 2011, what is the difference between the Rating of statistical capacity (0-100) in Methodology assessment and Rating of statistical capacity (0-100) in Overall level?
Provide a short and direct response. -26.67. In the year 2011, what is the difference between the Rating of statistical capacity (0-100) in Overall level and Rating of statistical capacity (0-100) in Periodicity assessment?
Your answer should be very brief. -23.33. In the year 2011, what is the difference between the Rating of statistical capacity (0-100) in Overall level and Rating of statistical capacity (0-100) in Source data assessment?
Give a very brief answer. -3.33. In the year 2011, what is the difference between the Rating of statistical capacity (0-100) of Periodicity assessment and Rating of statistical capacity (0-100) of Source data assessment?
Provide a short and direct response. 20. In the year 2012, what is the difference between the Rating of statistical capacity (0-100) of Overall level and Rating of statistical capacity (0-100) of Periodicity assessment?
Your response must be concise. -20. In the year 2012, what is the difference between the Rating of statistical capacity (0-100) in Overall level and Rating of statistical capacity (0-100) in Source data assessment?
Keep it short and to the point. -10. In the year 2012, what is the difference between the Rating of statistical capacity (0-100) of Periodicity assessment and Rating of statistical capacity (0-100) of Source data assessment?
Your answer should be very brief. 10. In the year 2013, what is the difference between the Rating of statistical capacity (0-100) in Methodology assessment and Rating of statistical capacity (0-100) in Source data assessment?
Provide a short and direct response. -40. In the year 2014, what is the difference between the Rating of statistical capacity (0-100) in Methodology assessment and Rating of statistical capacity (0-100) in Overall level?
Your answer should be compact. -26.67. In the year 2014, what is the difference between the Rating of statistical capacity (0-100) of Overall level and Rating of statistical capacity (0-100) of Periodicity assessment?
Keep it short and to the point. -13.33. In the year 2014, what is the difference between the Rating of statistical capacity (0-100) of Overall level and Rating of statistical capacity (0-100) of Source data assessment?
Offer a very short reply. -13.33. In the year 2014, what is the difference between the Rating of statistical capacity (0-100) in Periodicity assessment and Rating of statistical capacity (0-100) in Source data assessment?
Keep it short and to the point. 0. What is the ratio of the Rating of statistical capacity (0-100) in Overall level in 2006 to that in 2007?
Provide a succinct answer. 0.88. What is the ratio of the Rating of statistical capacity (0-100) in Periodicity assessment in 2006 to that in 2007?
Your answer should be very brief. 1.06. What is the ratio of the Rating of statistical capacity (0-100) of Methodology assessment in 2006 to that in 2008?
Provide a short and direct response. 0.5. What is the ratio of the Rating of statistical capacity (0-100) of Overall level in 2006 to that in 2008?
Your response must be concise. 0.78. What is the ratio of the Rating of statistical capacity (0-100) in Periodicity assessment in 2006 to that in 2008?
Provide a succinct answer. 0.95. What is the ratio of the Rating of statistical capacity (0-100) in Source data assessment in 2006 to that in 2008?
Provide a short and direct response. 0.71. What is the ratio of the Rating of statistical capacity (0-100) in Methodology assessment in 2006 to that in 2009?
Your response must be concise. 1. What is the ratio of the Rating of statistical capacity (0-100) in Overall level in 2006 to that in 2009?
Your answer should be compact. 0.97. What is the ratio of the Rating of statistical capacity (0-100) of Periodicity assessment in 2006 to that in 2009?
Give a very brief answer. 0.95. What is the ratio of the Rating of statistical capacity (0-100) in Source data assessment in 2006 to that in 2009?
Your answer should be very brief. 1. What is the ratio of the Rating of statistical capacity (0-100) in Source data assessment in 2006 to that in 2010?
Your answer should be very brief. 1. What is the ratio of the Rating of statistical capacity (0-100) in Overall level in 2006 to that in 2011?
Ensure brevity in your answer.  0.86. What is the ratio of the Rating of statistical capacity (0-100) in Overall level in 2006 to that in 2012?
Your response must be concise. 0.8. What is the ratio of the Rating of statistical capacity (0-100) in Source data assessment in 2006 to that in 2012?
Keep it short and to the point. 0.83. What is the ratio of the Rating of statistical capacity (0-100) in Overall level in 2006 to that in 2013?
Give a very brief answer. 0.8. What is the ratio of the Rating of statistical capacity (0-100) in Periodicity assessment in 2006 to that in 2013?
Make the answer very short. 0.86. What is the ratio of the Rating of statistical capacity (0-100) of Overall level in 2006 to that in 2014?
Your answer should be very brief. 0.86. What is the ratio of the Rating of statistical capacity (0-100) in Periodicity assessment in 2006 to that in 2014?
Your answer should be very brief. 1. What is the ratio of the Rating of statistical capacity (0-100) in Overall level in 2007 to that in 2008?
Your response must be concise. 0.89. What is the ratio of the Rating of statistical capacity (0-100) of Periodicity assessment in 2007 to that in 2008?
Your answer should be compact. 0.89. What is the ratio of the Rating of statistical capacity (0-100) in Source data assessment in 2007 to that in 2008?
Give a very brief answer. 0.86. What is the ratio of the Rating of statistical capacity (0-100) in Methodology assessment in 2007 to that in 2009?
Provide a succinct answer. 2. What is the ratio of the Rating of statistical capacity (0-100) in Overall level in 2007 to that in 2009?
Make the answer very short. 1.11. What is the ratio of the Rating of statistical capacity (0-100) of Periodicity assessment in 2007 to that in 2009?
Offer a very short reply. 0.89. What is the ratio of the Rating of statistical capacity (0-100) of Source data assessment in 2007 to that in 2009?
Your response must be concise. 1.2. What is the ratio of the Rating of statistical capacity (0-100) of Methodology assessment in 2007 to that in 2010?
Ensure brevity in your answer.  2. What is the ratio of the Rating of statistical capacity (0-100) of Overall level in 2007 to that in 2010?
Offer a terse response. 1.11. What is the ratio of the Rating of statistical capacity (0-100) of Periodicity assessment in 2007 to that in 2010?
Your answer should be very brief. 0.89. What is the ratio of the Rating of statistical capacity (0-100) in Methodology assessment in 2007 to that in 2011?
Your answer should be compact. 1. What is the ratio of the Rating of statistical capacity (0-100) in Overall level in 2007 to that in 2011?
Keep it short and to the point. 0.98. What is the ratio of the Rating of statistical capacity (0-100) in Periodicity assessment in 2007 to that in 2011?
Keep it short and to the point. 0.81. What is the ratio of the Rating of statistical capacity (0-100) in Overall level in 2007 to that in 2012?
Give a very brief answer. 0.91. What is the ratio of the Rating of statistical capacity (0-100) in Periodicity assessment in 2007 to that in 2012?
Provide a short and direct response. 0.81. What is the ratio of the Rating of statistical capacity (0-100) of Source data assessment in 2007 to that in 2012?
Keep it short and to the point. 1. What is the ratio of the Rating of statistical capacity (0-100) in Overall level in 2007 to that in 2013?
Your response must be concise. 0.91. What is the ratio of the Rating of statistical capacity (0-100) in Periodicity assessment in 2007 to that in 2013?
Offer a very short reply. 0.81. What is the ratio of the Rating of statistical capacity (0-100) of Overall level in 2007 to that in 2014?
Make the answer very short. 0.98. What is the ratio of the Rating of statistical capacity (0-100) in Periodicity assessment in 2007 to that in 2014?
Your answer should be compact. 0.94. What is the ratio of the Rating of statistical capacity (0-100) of Source data assessment in 2007 to that in 2014?
Offer a terse response. 1. What is the ratio of the Rating of statistical capacity (0-100) of Overall level in 2008 to that in 2009?
Your answer should be compact. 1.24. What is the ratio of the Rating of statistical capacity (0-100) in Source data assessment in 2008 to that in 2009?
Your answer should be compact. 1.4. What is the ratio of the Rating of statistical capacity (0-100) in Overall level in 2008 to that in 2010?
Provide a short and direct response. 1.24. What is the ratio of the Rating of statistical capacity (0-100) of Source data assessment in 2008 to that in 2010?
Your response must be concise. 1.4. What is the ratio of the Rating of statistical capacity (0-100) in Overall level in 2008 to that in 2011?
Your answer should be compact. 1.1. What is the ratio of the Rating of statistical capacity (0-100) in Periodicity assessment in 2008 to that in 2011?
Keep it short and to the point. 0.9. What is the ratio of the Rating of statistical capacity (0-100) in Methodology assessment in 2008 to that in 2012?
Provide a short and direct response. 1. What is the ratio of the Rating of statistical capacity (0-100) in Overall level in 2008 to that in 2012?
Keep it short and to the point. 1.02. What is the ratio of the Rating of statistical capacity (0-100) in Periodicity assessment in 2008 to that in 2012?
Give a very brief answer. 0.9. What is the ratio of the Rating of statistical capacity (0-100) in Overall level in 2008 to that in 2013?
Your answer should be compact. 1.02. What is the ratio of the Rating of statistical capacity (0-100) of Periodicity assessment in 2008 to that in 2013?
Give a very brief answer. 0.9. What is the ratio of the Rating of statistical capacity (0-100) of Methodology assessment in 2008 to that in 2014?
Provide a succinct answer. 1. What is the ratio of the Rating of statistical capacity (0-100) in Overall level in 2008 to that in 2014?
Your answer should be compact. 1.1. What is the ratio of the Rating of statistical capacity (0-100) of Periodicity assessment in 2008 to that in 2014?
Make the answer very short. 1.06. What is the ratio of the Rating of statistical capacity (0-100) in Overall level in 2009 to that in 2010?
Your answer should be compact. 1. What is the ratio of the Rating of statistical capacity (0-100) in Source data assessment in 2009 to that in 2010?
Provide a succinct answer. 1. What is the ratio of the Rating of statistical capacity (0-100) of Methodology assessment in 2009 to that in 2011?
Provide a short and direct response. 0.5. What is the ratio of the Rating of statistical capacity (0-100) of Overall level in 2009 to that in 2011?
Give a very brief answer. 0.88. What is the ratio of the Rating of statistical capacity (0-100) of Periodicity assessment in 2009 to that in 2011?
Keep it short and to the point. 0.9. What is the ratio of the Rating of statistical capacity (0-100) of Source data assessment in 2009 to that in 2011?
Make the answer very short. 1. What is the ratio of the Rating of statistical capacity (0-100) in Methodology assessment in 2009 to that in 2012?
Offer a terse response. 0.5. What is the ratio of the Rating of statistical capacity (0-100) in Overall level in 2009 to that in 2012?
Ensure brevity in your answer.  0.82. What is the ratio of the Rating of statistical capacity (0-100) of Periodicity assessment in 2009 to that in 2012?
Give a very brief answer. 0.9. What is the ratio of the Rating of statistical capacity (0-100) in Source data assessment in 2009 to that in 2012?
Your response must be concise. 0.83. What is the ratio of the Rating of statistical capacity (0-100) of Overall level in 2009 to that in 2013?
Your answer should be compact. 0.82. What is the ratio of the Rating of statistical capacity (0-100) in Periodicity assessment in 2009 to that in 2013?
Give a very brief answer. 0.9. What is the ratio of the Rating of statistical capacity (0-100) of Overall level in 2009 to that in 2014?
Give a very brief answer. 0.88. What is the ratio of the Rating of statistical capacity (0-100) of Periodicity assessment in 2009 to that in 2014?
Your answer should be very brief. 1.06. What is the ratio of the Rating of statistical capacity (0-100) of Methodology assessment in 2010 to that in 2011?
Make the answer very short. 0.5. What is the ratio of the Rating of statistical capacity (0-100) of Overall level in 2010 to that in 2011?
Offer a terse response. 0.88. What is the ratio of the Rating of statistical capacity (0-100) in Periodicity assessment in 2010 to that in 2011?
Offer a terse response. 0.9. What is the ratio of the Rating of statistical capacity (0-100) in Source data assessment in 2010 to that in 2011?
Make the answer very short. 1. What is the ratio of the Rating of statistical capacity (0-100) in Methodology assessment in 2010 to that in 2012?
Provide a short and direct response. 0.5. What is the ratio of the Rating of statistical capacity (0-100) in Overall level in 2010 to that in 2012?
Make the answer very short. 0.82. What is the ratio of the Rating of statistical capacity (0-100) of Periodicity assessment in 2010 to that in 2012?
Provide a short and direct response. 0.9. What is the ratio of the Rating of statistical capacity (0-100) of Overall level in 2010 to that in 2013?
Ensure brevity in your answer.  0.82. What is the ratio of the Rating of statistical capacity (0-100) of Periodicity assessment in 2010 to that in 2013?
Keep it short and to the point. 0.9. What is the ratio of the Rating of statistical capacity (0-100) in Source data assessment in 2010 to that in 2013?
Your answer should be very brief. 0.83. What is the ratio of the Rating of statistical capacity (0-100) in Methodology assessment in 2010 to that in 2014?
Keep it short and to the point. 0.5. What is the ratio of the Rating of statistical capacity (0-100) of Overall level in 2010 to that in 2014?
Provide a short and direct response. 0.88. What is the ratio of the Rating of statistical capacity (0-100) in Periodicity assessment in 2010 to that in 2014?
Make the answer very short. 1.06. What is the ratio of the Rating of statistical capacity (0-100) of Source data assessment in 2010 to that in 2014?
Your response must be concise. 0.83. What is the ratio of the Rating of statistical capacity (0-100) in Methodology assessment in 2011 to that in 2012?
Your answer should be compact. 1. What is the ratio of the Rating of statistical capacity (0-100) in Overall level in 2011 to that in 2012?
Provide a short and direct response. 0.93. What is the ratio of the Rating of statistical capacity (0-100) of Periodicity assessment in 2011 to that in 2012?
Give a very brief answer. 1. What is the ratio of the Rating of statistical capacity (0-100) of Source data assessment in 2011 to that in 2012?
Keep it short and to the point. 0.83. What is the ratio of the Rating of statistical capacity (0-100) in Source data assessment in 2011 to that in 2013?
Make the answer very short. 0.83. What is the ratio of the Rating of statistical capacity (0-100) of Source data assessment in 2011 to that in 2014?
Provide a succinct answer. 0.83. What is the ratio of the Rating of statistical capacity (0-100) of Methodology assessment in 2012 to that in 2013?
Provide a short and direct response. 1. What is the ratio of the Rating of statistical capacity (0-100) in Overall level in 2012 to that in 2013?
Provide a succinct answer. 1. What is the ratio of the Rating of statistical capacity (0-100) of Periodicity assessment in 2012 to that in 2013?
Give a very brief answer. 1. What is the ratio of the Rating of statistical capacity (0-100) of Overall level in 2012 to that in 2014?
Give a very brief answer. 1.07. What is the ratio of the Rating of statistical capacity (0-100) of Methodology assessment in 2013 to that in 2014?
Make the answer very short. 1. What is the ratio of the Rating of statistical capacity (0-100) of Overall level in 2013 to that in 2014?
Offer a very short reply. 1.07. What is the ratio of the Rating of statistical capacity (0-100) of Periodicity assessment in 2013 to that in 2014?
Your answer should be very brief. 1.17. What is the difference between the highest and the second highest Rating of statistical capacity (0-100) in Periodicity assessment?
Provide a succinct answer. 0. What is the difference between the highest and the second highest Rating of statistical capacity (0-100) of Source data assessment?
Provide a succinct answer. 10. What is the difference between the highest and the lowest Rating of statistical capacity (0-100) in Methodology assessment?
Your answer should be compact. 10. What is the difference between the highest and the lowest Rating of statistical capacity (0-100) in Overall level?
Make the answer very short. 11.11. What is the difference between the highest and the lowest Rating of statistical capacity (0-100) in Periodicity assessment?
Keep it short and to the point. 13.33. 